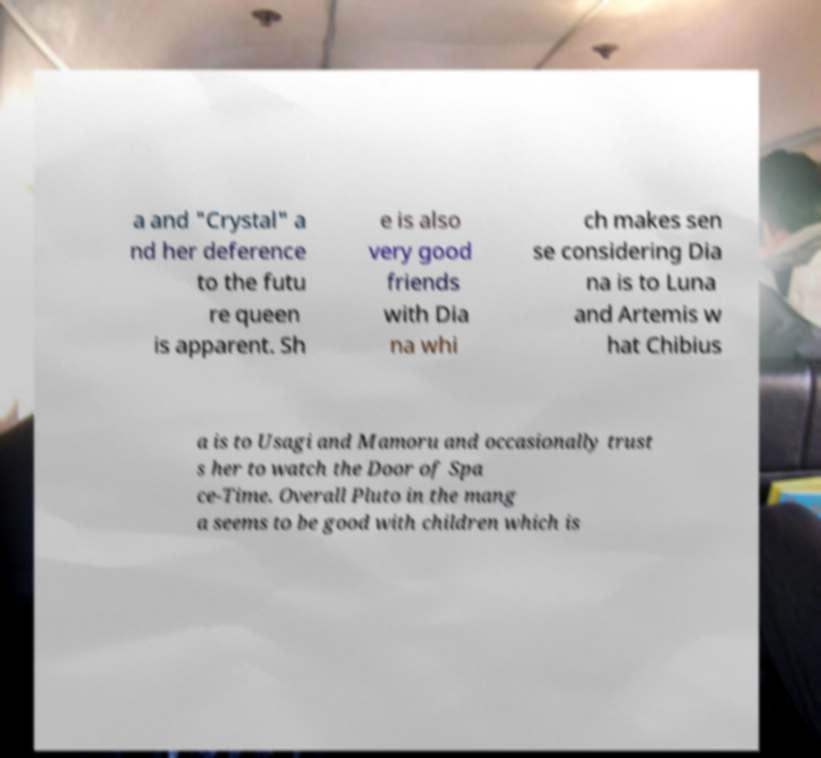Please read and relay the text visible in this image. What does it say? a and "Crystal" a nd her deference to the futu re queen is apparent. Sh e is also very good friends with Dia na whi ch makes sen se considering Dia na is to Luna and Artemis w hat Chibius a is to Usagi and Mamoru and occasionally trust s her to watch the Door of Spa ce-Time. Overall Pluto in the mang a seems to be good with children which is 